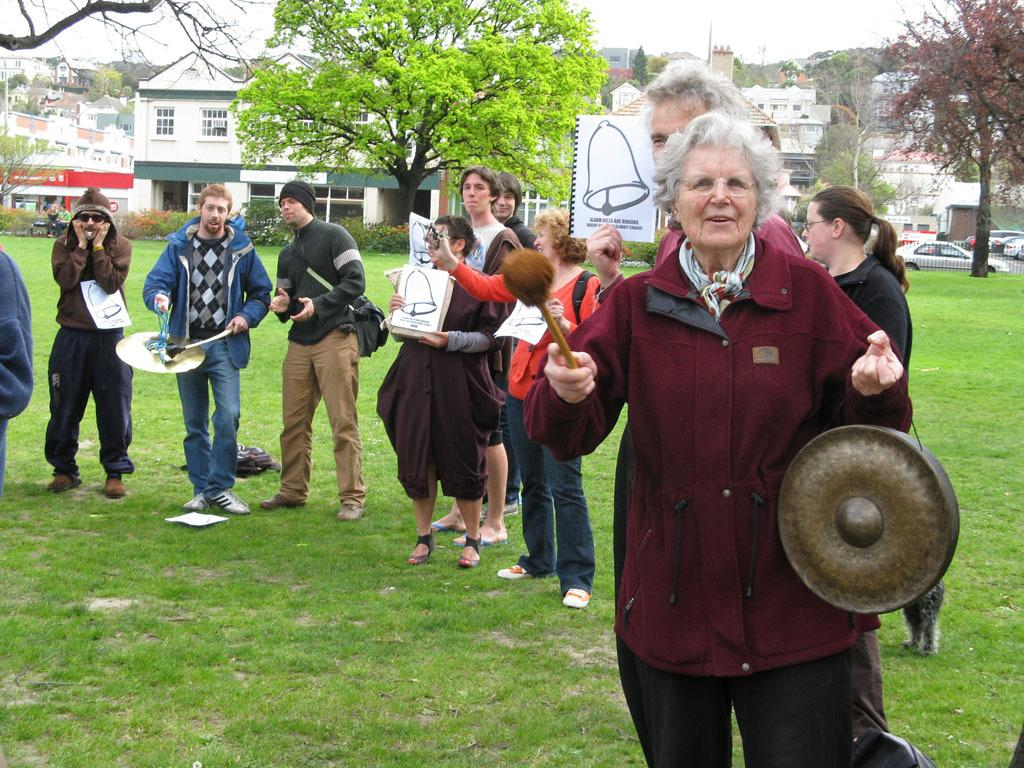Who is the main subject on the right side of the image? There is an old woman standing on the right side of the image. What is the old woman wearing? The old woman is wearing a dark red color. What can be seen in the middle of the image? There is a green tree in the middle of the image. What is visible behind the tree? There are buildings visible behind the tree. What type of disease is affecting the tree in the image? There is no indication of any disease affecting the tree in the image; it appears to be a healthy green tree. What kind of powder can be seen falling from the sky in the image? There is no powder falling from the sky in the image; the sky is clear. 